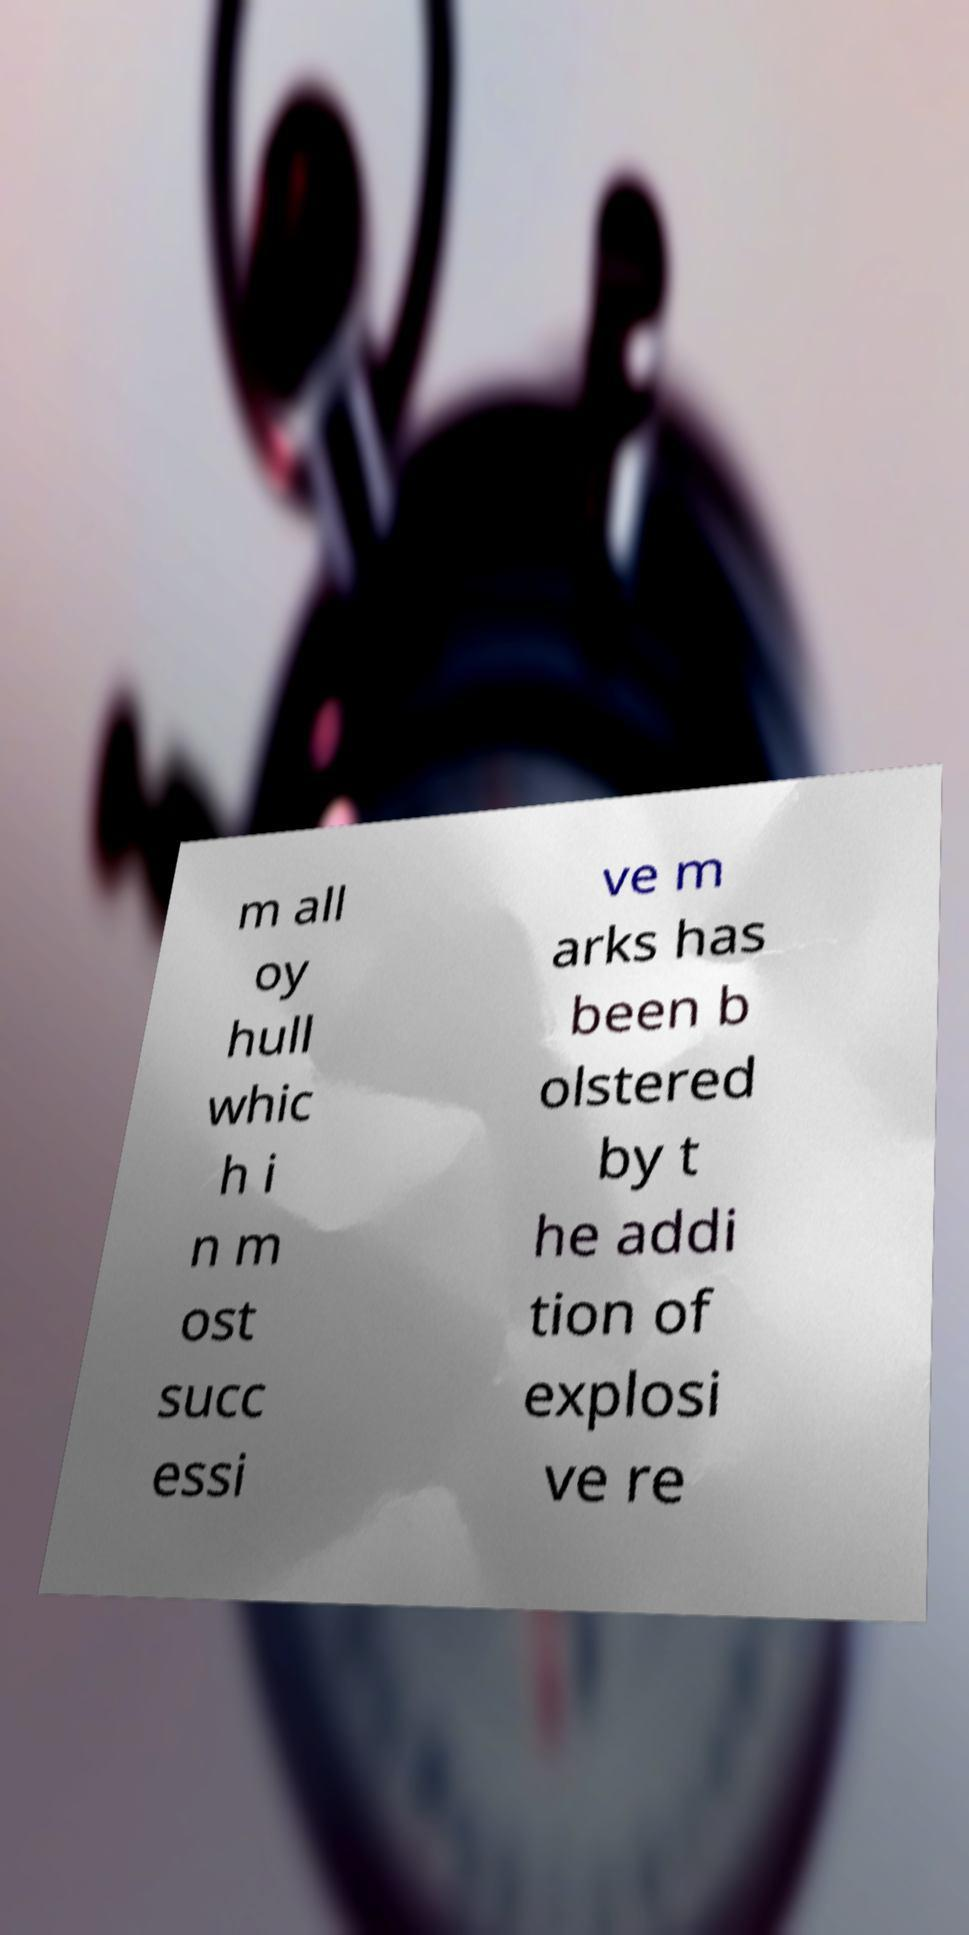Can you accurately transcribe the text from the provided image for me? m all oy hull whic h i n m ost succ essi ve m arks has been b olstered by t he addi tion of explosi ve re 